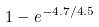<formula> <loc_0><loc_0><loc_500><loc_500>1 - e ^ { - 4 . 7 / 4 . 5 }</formula> 